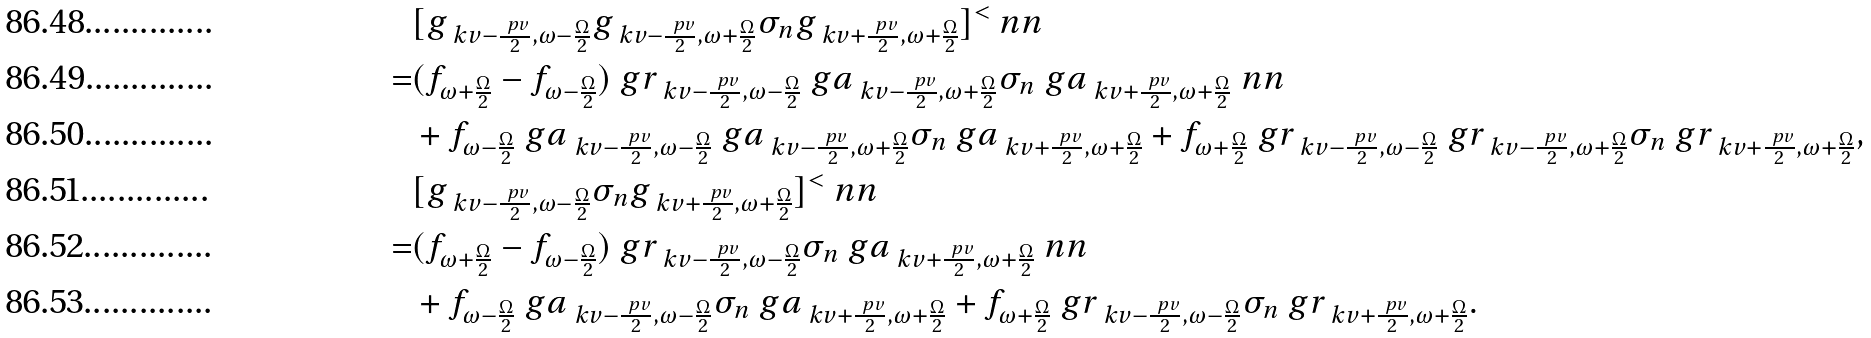<formula> <loc_0><loc_0><loc_500><loc_500>& [ g _ { \ k v - \frac { \ p v } { 2 } , \omega - \frac { \Omega } { 2 } } g _ { \ k v - \frac { \ p v } { 2 } , \omega + \frac { \Omega } { 2 } } \sigma _ { n } g _ { \ k v + \frac { \ p v } { 2 } , \omega + \frac { \Omega } { 2 } } ] ^ { < } \ n n \\ = & ( f _ { \omega + \frac { \Omega } { 2 } } - f _ { \omega - \frac { \Omega } { 2 } } ) \ g r _ { \ k v - \frac { \ p v } { 2 } , \omega - \frac { \Omega } { 2 } } \ g a _ { \ k v - \frac { \ p v } { 2 } , \omega + \frac { \Omega } { 2 } } \sigma _ { n } \ g a _ { \ k v + \frac { \ p v } { 2 } , \omega + \frac { \Omega } { 2 } } \ n n \\ & + f _ { \omega - \frac { \Omega } { 2 } } \ g a _ { \ k v - \frac { \ p v } { 2 } , \omega - \frac { \Omega } { 2 } } \ g a _ { \ k v - \frac { \ p v } { 2 } , \omega + \frac { \Omega } { 2 } } \sigma _ { n } \ g a _ { \ k v + \frac { \ p v } { 2 } , \omega + \frac { \Omega } { 2 } } + f _ { \omega + \frac { \Omega } { 2 } } \ g r _ { \ k v - \frac { \ p v } { 2 } , \omega - \frac { \Omega } { 2 } } \ g r _ { \ k v - \frac { \ p v } { 2 } , \omega + \frac { \Omega } { 2 } } \sigma _ { n } \ g r _ { \ k v + \frac { \ p v } { 2 } , \omega + \frac { \Omega } { 2 } } , \\ & [ g _ { \ k v - \frac { \ p v } { 2 } , \omega - \frac { \Omega } { 2 } } \sigma _ { n } g _ { \ k v + \frac { \ p v } { 2 } , \omega + \frac { \Omega } { 2 } } ] ^ { < } \ n n \\ = & ( f _ { \omega + \frac { \Omega } { 2 } } - f _ { \omega - \frac { \Omega } { 2 } } ) \ g r _ { \ k v - \frac { \ p v } { 2 } , \omega - \frac { \Omega } { 2 } } \sigma _ { n } \ g a _ { \ k v + \frac { \ p v } { 2 } , \omega + \frac { \Omega } { 2 } } \ n n \\ & + f _ { \omega - \frac { \Omega } { 2 } } \ g a _ { \ k v - \frac { \ p v } { 2 } , \omega - \frac { \Omega } { 2 } } \sigma _ { n } \ g a _ { \ k v + \frac { \ p v } { 2 } , \omega + \frac { \Omega } { 2 } } + f _ { \omega + \frac { \Omega } { 2 } } \ g r _ { \ k v - \frac { \ p v } { 2 } , \omega - \frac { \Omega } { 2 } } \sigma _ { n } \ g r _ { \ k v + \frac { \ p v } { 2 } , \omega + \frac { \Omega } { 2 } } .</formula> 